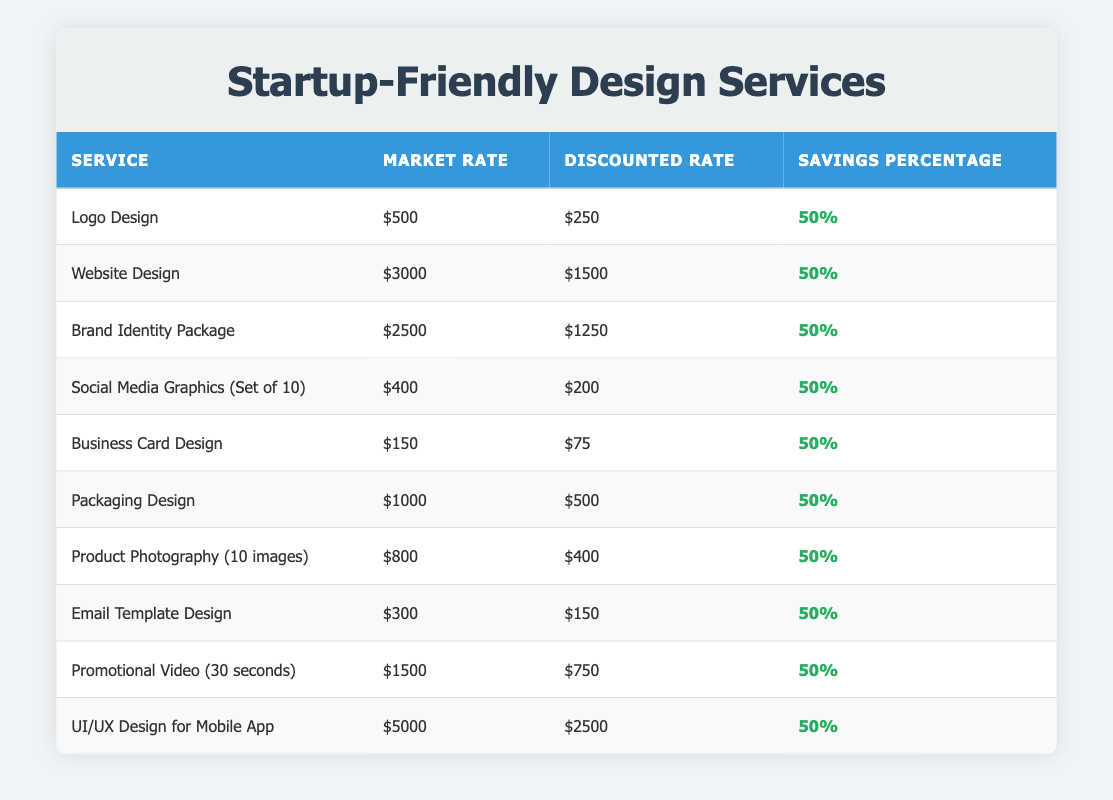What is the discounted rate for Website Design? The table shows that the discounted rate for Website Design is listed directly under the "Discounted Rate" column next to the corresponding service. By locating "Website Design," I can see that the discounted rate is $1500.
Answer: $1500 What is the savings percentage for Social Media Graphics? Checking the "Savings Percentage" column for Social Media Graphics, I find that it states 50%. This indicates the percentage saved compared to the market rate.
Answer: 50% Which service has the highest market rate? To identify the service with the highest market rate, I compare the market rates listed in the second column. The maximum value is found next to "UI/UX Design for Mobile App," which has a market rate of $5000.
Answer: UI/UX Design for Mobile App If a client avails of the Business Card Design service, how much will they save in dollars? The market rate for Business Card Design is $150, and the discounted rate is $75. The savings in dollars can be calculated by subtracting the discounted rate from the market rate: $150 - $75 = $75.
Answer: $75 Is the average savings percentage across all services the same? In the table, the savings percentage for all services is consistently stated as 50%. Therefore, the average savings percentage can also be evaluated by comparing these consistent entries; since they are all equal, the answer is yes.
Answer: Yes What is the total cost for all discounted services combined? To find this, I sum up all the discounted rates: $250 + $1500 + $1250 + $200 + $75 + $500 + $400 + $150 + $750 + $2500 = $6260. Thus, the total cost for all discounted services amounts to $6260.
Answer: $6260 Is there any service where the savings percentage is greater than 50%? I can review the entire savings percentage column for each service. Since all entries consistently show 50%, there are no services with a savings percentage greater than this value.
Answer: No What is the difference between the highest discounted rate and the lowest discounted rate? The highest discounted rate from the table is for the UI/UX Design for Mobile App at $2500, while the lowest discounted rate is for Business Card Design at $75. The difference can be calculated as $2500 - $75 = $2425.
Answer: $2425 